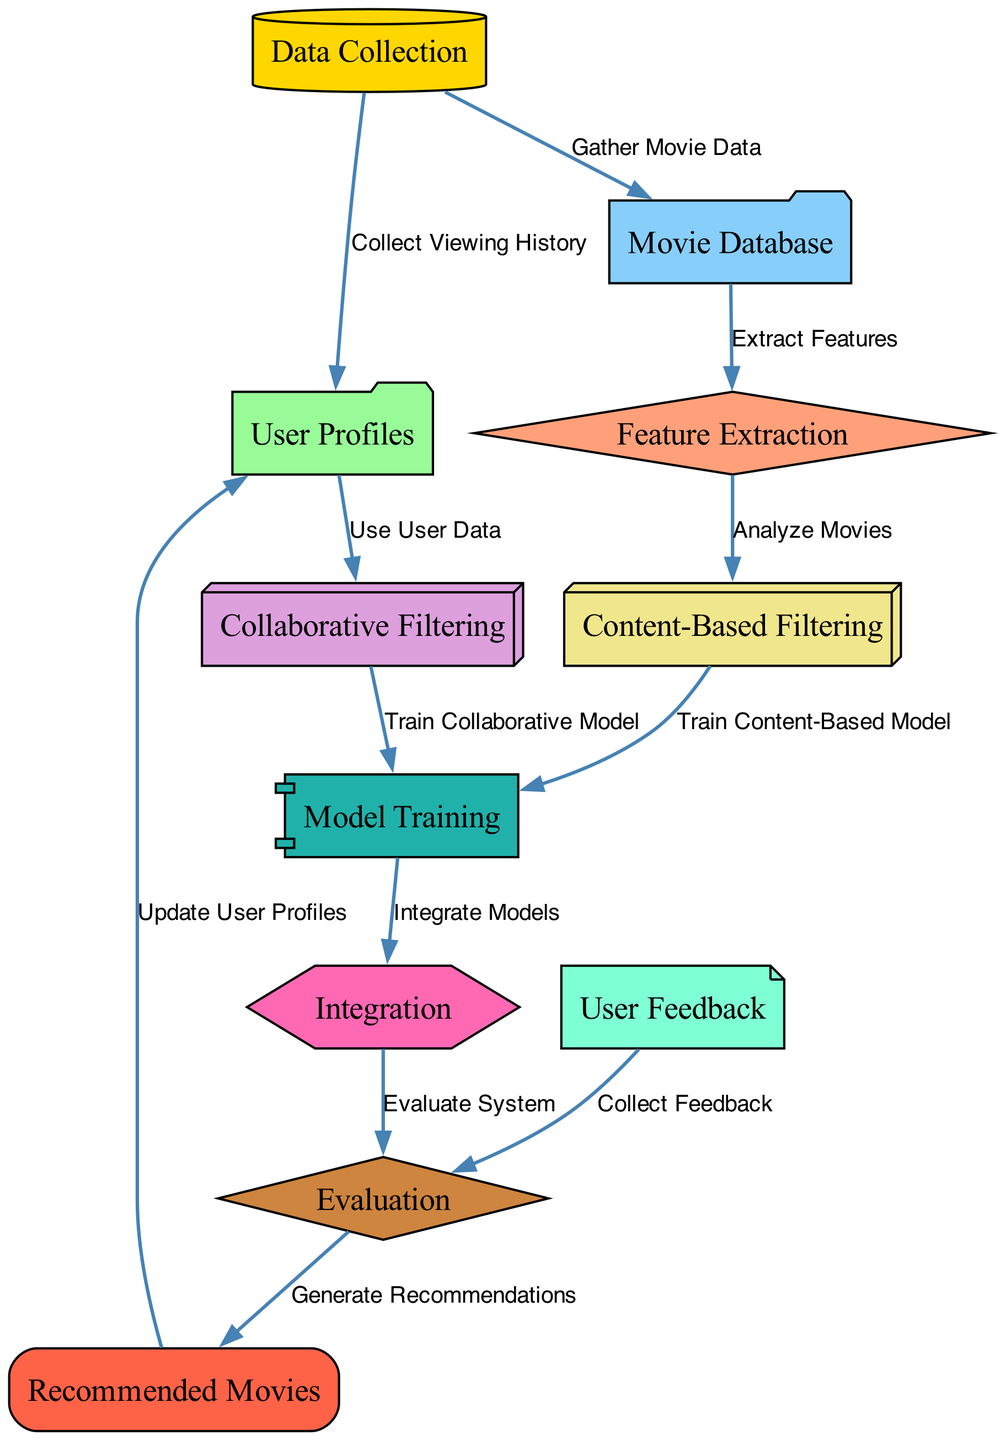What are the two main types of filtering used in the diagram? The diagram lists "Collaborative Filtering" and "Content-Based Filtering" as the two distinct filtering methods utilized after feature extraction and user data utilization.
Answer: Collaborative Filtering, Content-Based Filtering How many nodes are present in the diagram? By counting the labeled boxes representing the different components, we see that there are a total of 11 nodes in the diagram.
Answer: 11 What does the "Evaluation" node connect to? The "Evaluation" node has edges connecting it to "Integration" and "User Feedback," indicating that it evaluates the system's performance based on both model integration and user feedback.
Answer: Integration, User Feedback Which process comes after "Model Training"? The diagram clearly shows that the next process after "Model Training" is "Integration," where the models are combined for further evaluation.
Answer: Integration What is the purpose of "User Profiles" in the system? "User Profiles" are utilized to collect viewing history and feed into the collaborative filtering process, which helps in personalizing recommendations based on users' past behaviors.
Answer: Personalization Which node is classified as a "diamond" shape? According to the diagram, "Feature Extraction" and "Evaluation" are represented as diamond-shaped nodes, indicating key decision points in the recommendation process.
Answer: Feature Extraction, Evaluation How does user feedback influence the recommender system? User feedback connects back to the "Evaluation" process, indicating that it is used to improve the recommendation algorithm over time by collecting user preferences and adjustments.
Answer: Improve recommendations What is the first step in building the recommender system? The first step highlighted in the diagram is "Data Collection," which involves gathering both viewing history and movie data as fundamental inputs for the entire system.
Answer: Data Collection 